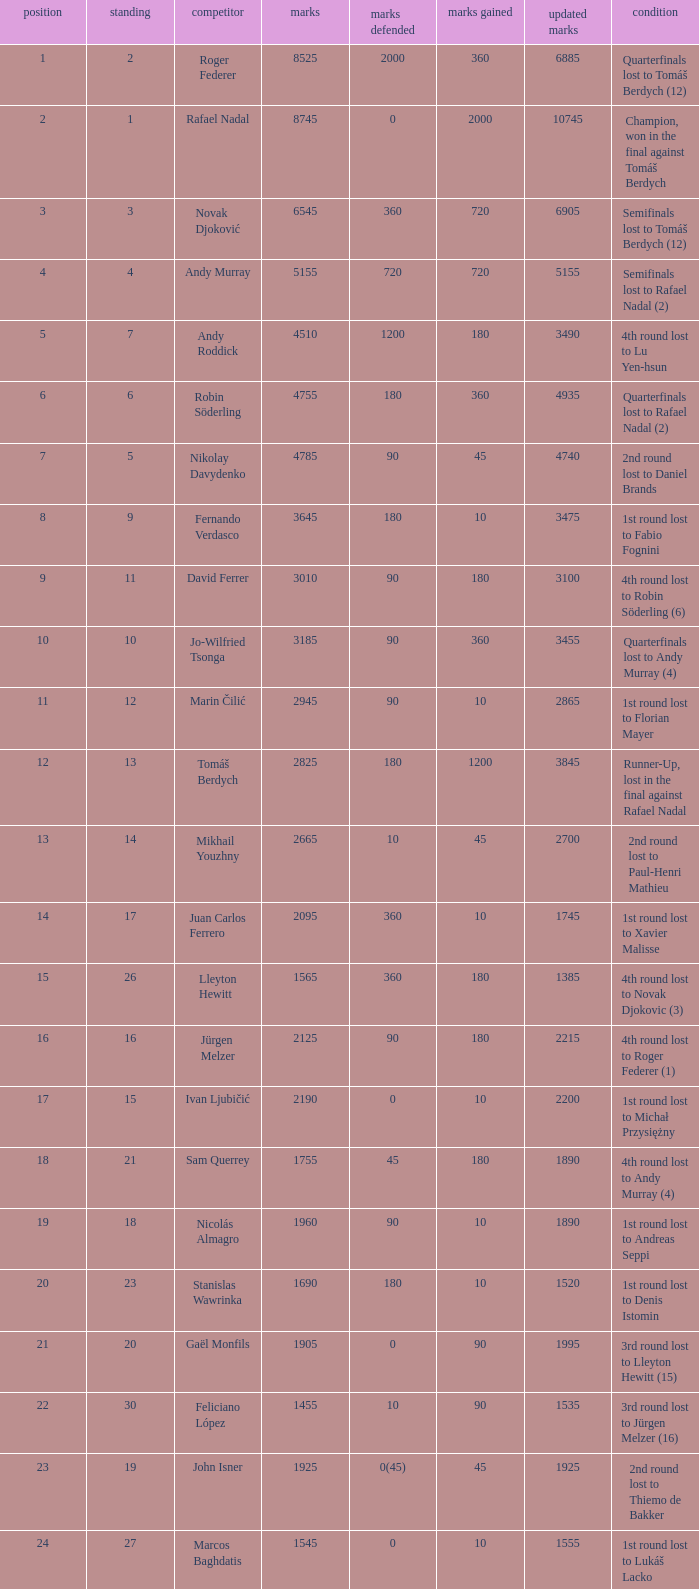Name the least new points for points defending is 1200 3490.0. 